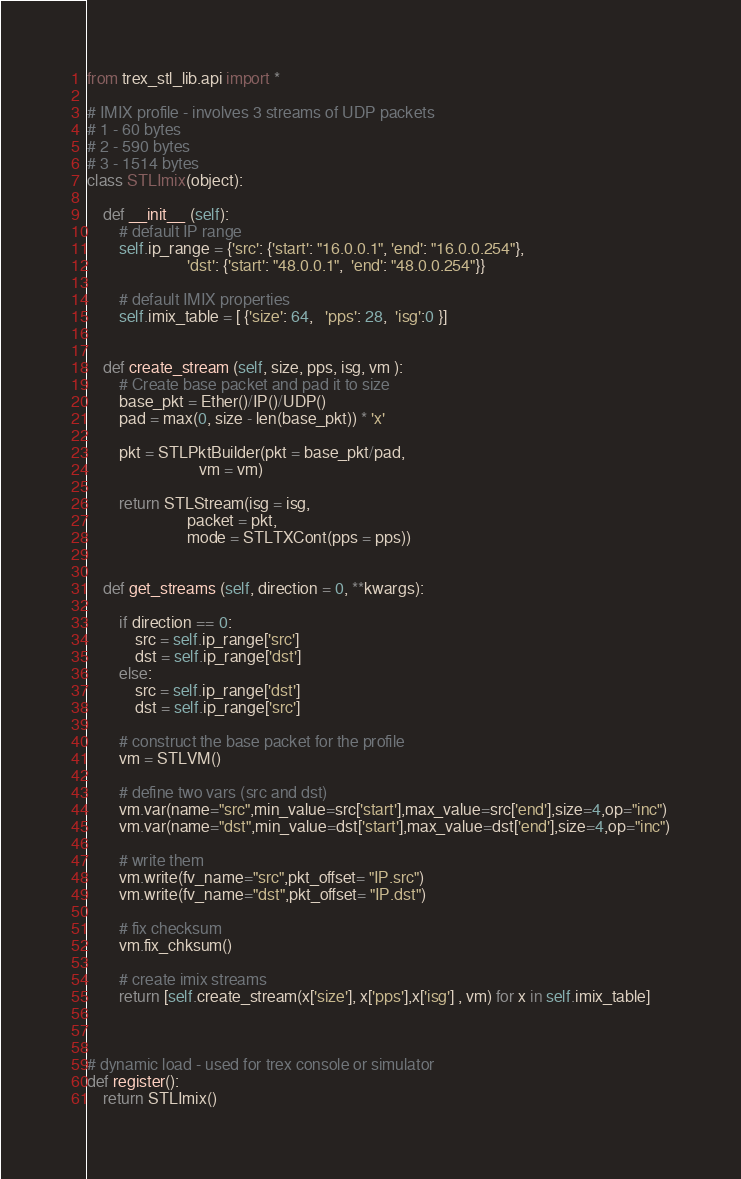Convert code to text. <code><loc_0><loc_0><loc_500><loc_500><_Python_>from trex_stl_lib.api import *

# IMIX profile - involves 3 streams of UDP packets
# 1 - 60 bytes
# 2 - 590 bytes
# 3 - 1514 bytes
class STLImix(object):

    def __init__ (self):
        # default IP range
        self.ip_range = {'src': {'start': "16.0.0.1", 'end': "16.0.0.254"},
                         'dst': {'start': "48.0.0.1",  'end': "48.0.0.254"}}

        # default IMIX properties
        self.imix_table = [ {'size': 64,   'pps': 28,  'isg':0 }]


    def create_stream (self, size, pps, isg, vm ):
        # Create base packet and pad it to size
        base_pkt = Ether()/IP()/UDP()
        pad = max(0, size - len(base_pkt)) * 'x'

        pkt = STLPktBuilder(pkt = base_pkt/pad,
                            vm = vm)

        return STLStream(isg = isg,
                         packet = pkt,
                         mode = STLTXCont(pps = pps))


    def get_streams (self, direction = 0, **kwargs):

        if direction == 0:
            src = self.ip_range['src']
            dst = self.ip_range['dst']
        else:
            src = self.ip_range['dst']
            dst = self.ip_range['src']

        # construct the base packet for the profile
        vm = STLVM()
        
        # define two vars (src and dst)
        vm.var(name="src",min_value=src['start'],max_value=src['end'],size=4,op="inc")
        vm.var(name="dst",min_value=dst['start'],max_value=dst['end'],size=4,op="inc")
        
        # write them
        vm.write(fv_name="src",pkt_offset= "IP.src")
        vm.write(fv_name="dst",pkt_offset= "IP.dst")
        
        # fix checksum
        vm.fix_chksum()
        
        # create imix streams
        return [self.create_stream(x['size'], x['pps'],x['isg'] , vm) for x in self.imix_table]



# dynamic load - used for trex console or simulator
def register():
    return STLImix()



</code> 